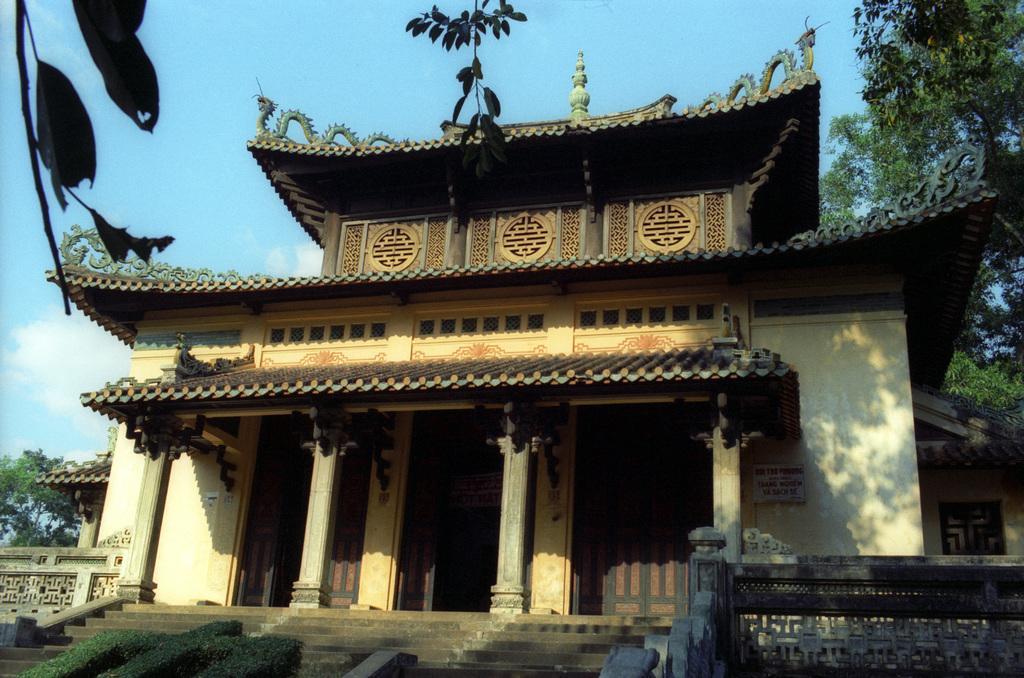How would you summarize this image in a sentence or two? In this image we can see there is a building. There are walls, trees and bushes. In the background we can see the sky. 